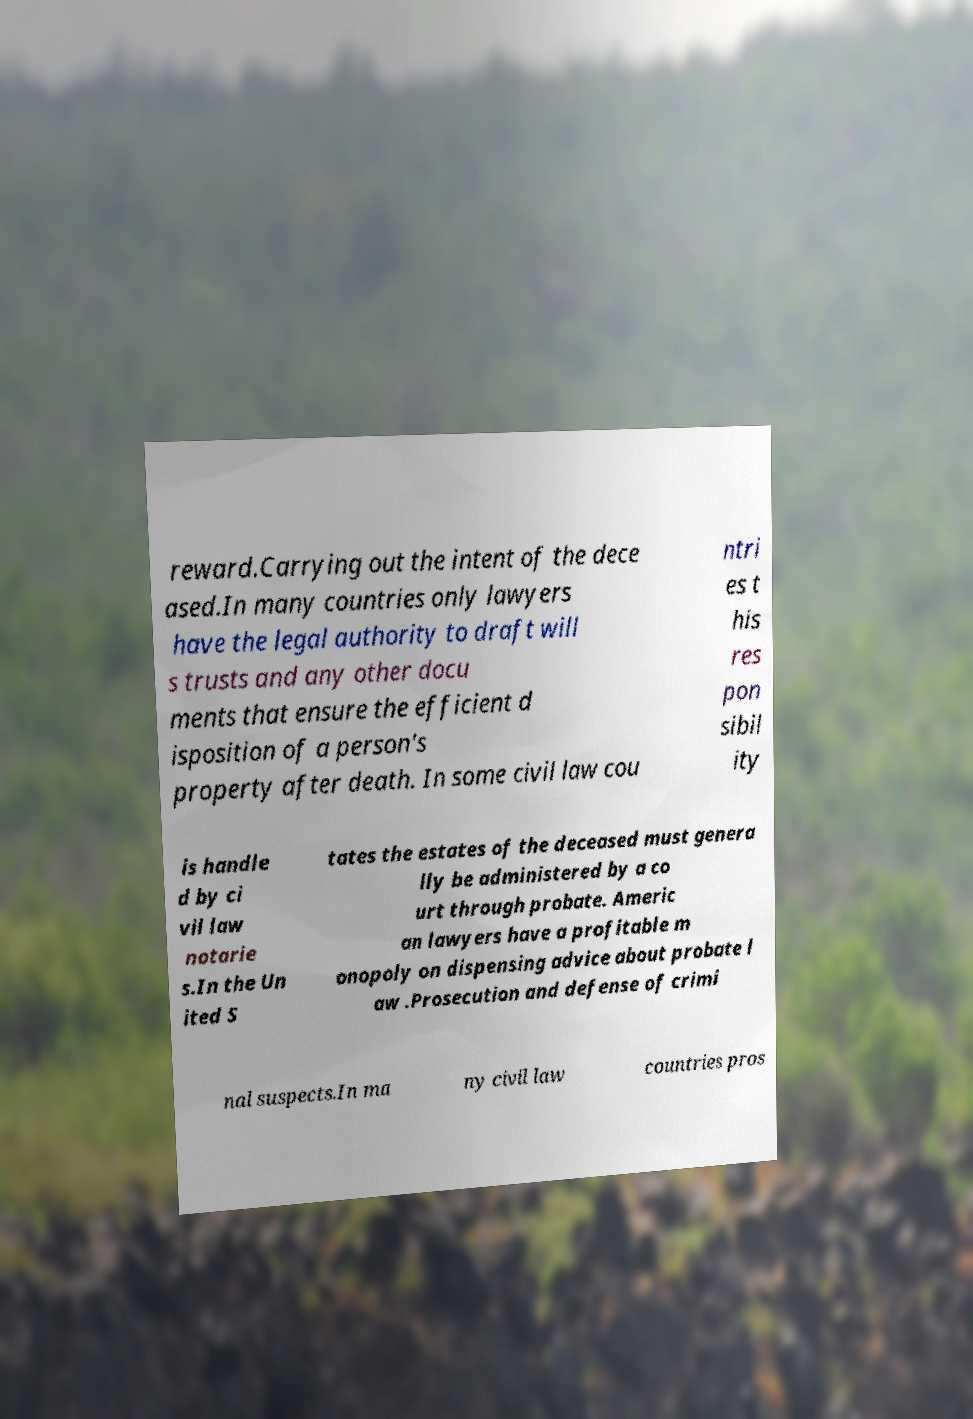Could you assist in decoding the text presented in this image and type it out clearly? reward.Carrying out the intent of the dece ased.In many countries only lawyers have the legal authority to draft will s trusts and any other docu ments that ensure the efficient d isposition of a person's property after death. In some civil law cou ntri es t his res pon sibil ity is handle d by ci vil law notarie s.In the Un ited S tates the estates of the deceased must genera lly be administered by a co urt through probate. Americ an lawyers have a profitable m onopoly on dispensing advice about probate l aw .Prosecution and defense of crimi nal suspects.In ma ny civil law countries pros 